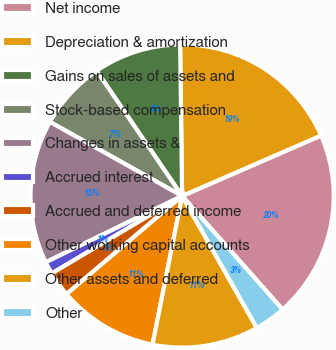Convert chart to OTSL. <chart><loc_0><loc_0><loc_500><loc_500><pie_chart><fcel>Net income<fcel>Depreciation & amortization<fcel>Gains on sales of assets and<fcel>Stock-based compensation<fcel>Changes in assets &<fcel>Accrued interest<fcel>Accrued and deferred income<fcel>Other working capital accounts<fcel>Other assets and deferred<fcel>Other<nl><fcel>20.0%<fcel>18.67%<fcel>9.33%<fcel>7.33%<fcel>15.33%<fcel>1.33%<fcel>2.67%<fcel>10.67%<fcel>11.33%<fcel>3.33%<nl></chart> 